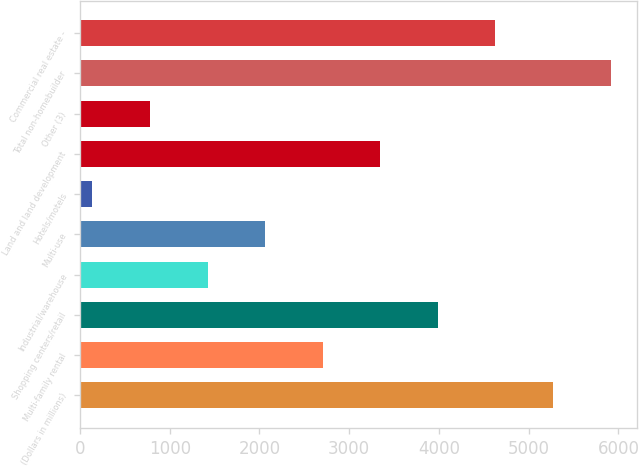<chart> <loc_0><loc_0><loc_500><loc_500><bar_chart><fcel>(Dollars in millions)<fcel>Multi-family rental<fcel>Shopping centers/retail<fcel>Industrial/warehouse<fcel>Multi-use<fcel>Hotels/motels<fcel>Land and land development<fcel>Other (3)<fcel>Total non-homebuilder<fcel>Commercial real estate -<nl><fcel>5271<fcel>2705<fcel>3988<fcel>1422<fcel>2063.5<fcel>139<fcel>3346.5<fcel>780.5<fcel>5912.5<fcel>4629.5<nl></chart> 